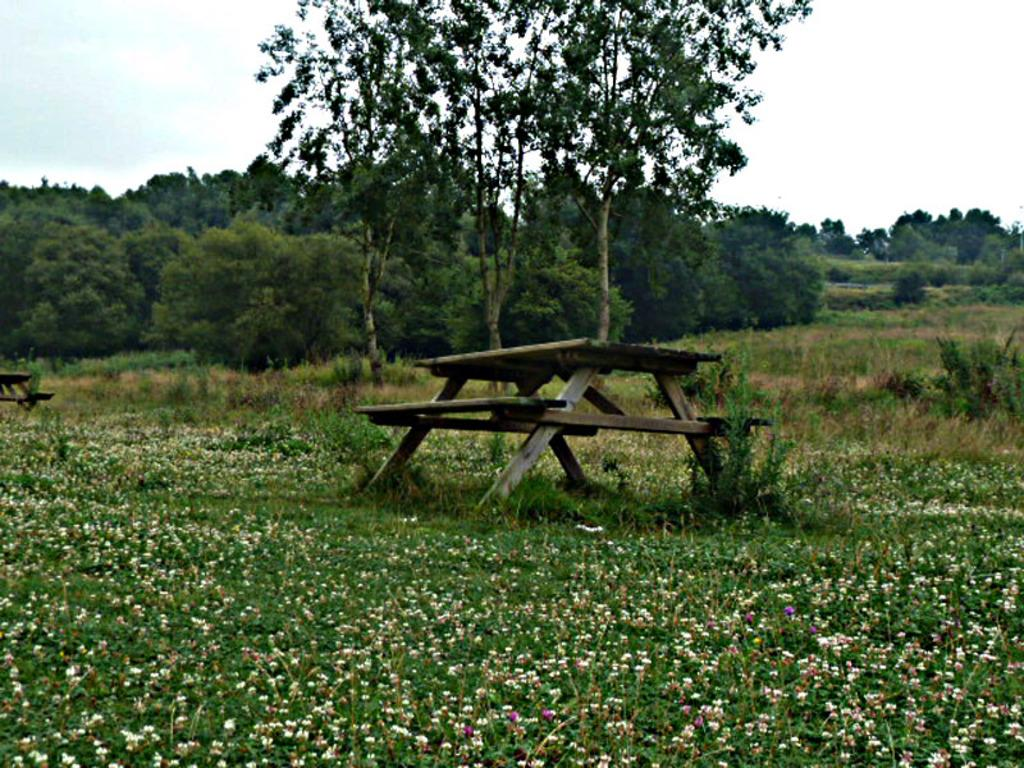What type of vegetation is present in the image? There are trees in the image. What type of ground cover is present in the image? There is grass in the image. What type of furniture is present in the image? There is a table and a bench in the image. What part of the natural environment is visible in the image? The sky is visible in the image. Can you tell me how many women are shaking hands in the image? There are no women or handshakes present in the image. What type of vehicle is visible in the image? There is no vehicle present in the image. 